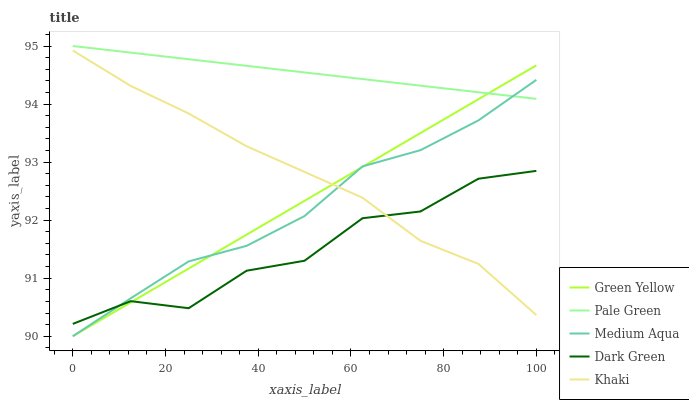Does Dark Green have the minimum area under the curve?
Answer yes or no. Yes. Does Pale Green have the maximum area under the curve?
Answer yes or no. Yes. Does Green Yellow have the minimum area under the curve?
Answer yes or no. No. Does Green Yellow have the maximum area under the curve?
Answer yes or no. No. Is Green Yellow the smoothest?
Answer yes or no. Yes. Is Dark Green the roughest?
Answer yes or no. Yes. Is Medium Aqua the smoothest?
Answer yes or no. No. Is Medium Aqua the roughest?
Answer yes or no. No. Does Green Yellow have the lowest value?
Answer yes or no. Yes. Does Khaki have the lowest value?
Answer yes or no. No. Does Pale Green have the highest value?
Answer yes or no. Yes. Does Green Yellow have the highest value?
Answer yes or no. No. Is Khaki less than Pale Green?
Answer yes or no. Yes. Is Pale Green greater than Khaki?
Answer yes or no. Yes. Does Green Yellow intersect Khaki?
Answer yes or no. Yes. Is Green Yellow less than Khaki?
Answer yes or no. No. Is Green Yellow greater than Khaki?
Answer yes or no. No. Does Khaki intersect Pale Green?
Answer yes or no. No. 